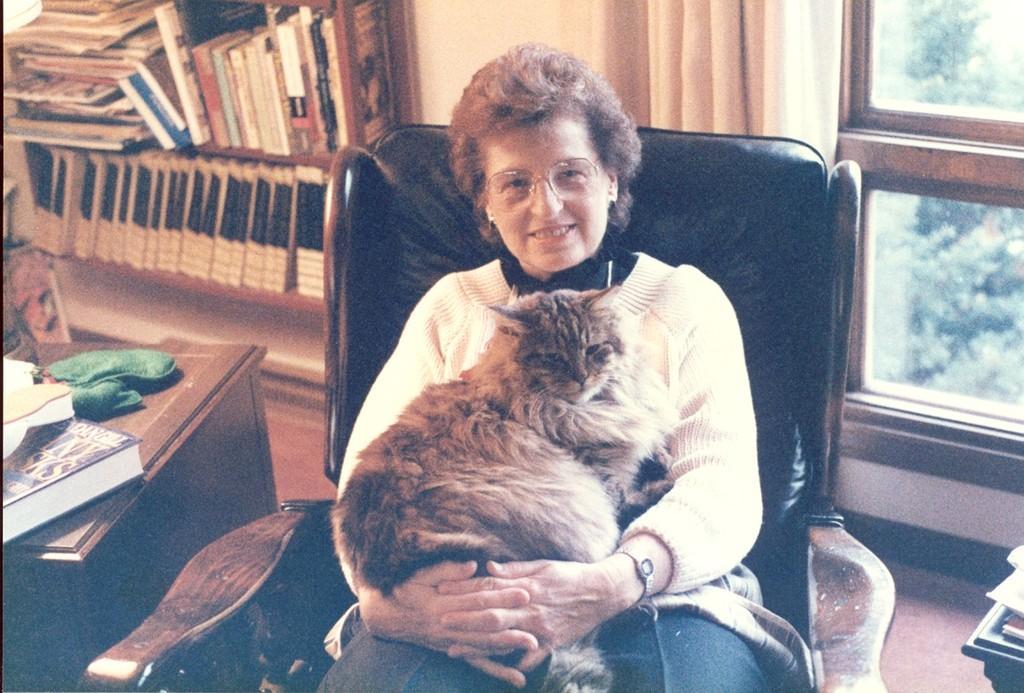In one or two sentences, can you explain what this image depicts? This is the women siting on the chair and holding a fluffy cat. This is a table with a book and some object which is green in color. These are the books placed in the rack. I think this is the bookshelf. This is the curtain hanging. This looks like the window which is closed. 